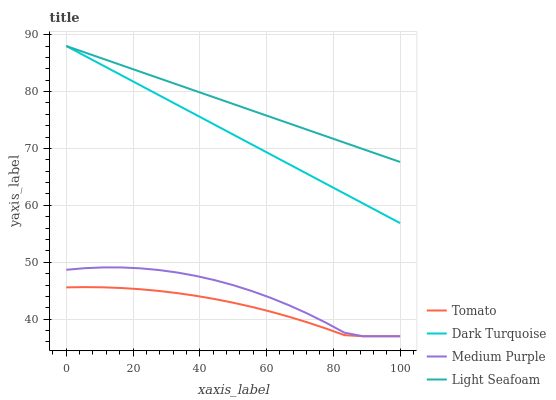Does Tomato have the minimum area under the curve?
Answer yes or no. Yes. Does Light Seafoam have the maximum area under the curve?
Answer yes or no. Yes. Does Dark Turquoise have the minimum area under the curve?
Answer yes or no. No. Does Dark Turquoise have the maximum area under the curve?
Answer yes or no. No. Is Light Seafoam the smoothest?
Answer yes or no. Yes. Is Medium Purple the roughest?
Answer yes or no. Yes. Is Dark Turquoise the smoothest?
Answer yes or no. No. Is Dark Turquoise the roughest?
Answer yes or no. No. Does Dark Turquoise have the lowest value?
Answer yes or no. No. Does Medium Purple have the highest value?
Answer yes or no. No. Is Tomato less than Light Seafoam?
Answer yes or no. Yes. Is Dark Turquoise greater than Medium Purple?
Answer yes or no. Yes. Does Tomato intersect Light Seafoam?
Answer yes or no. No. 